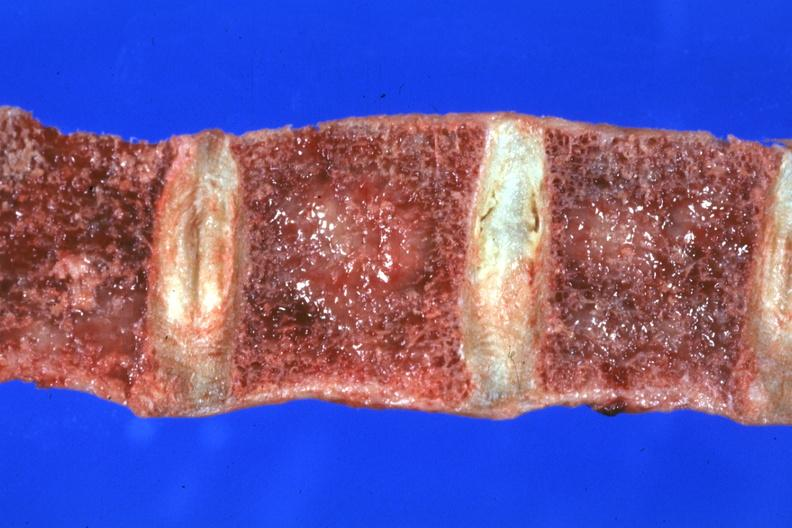what is present?
Answer the question using a single word or phrase. Joints 